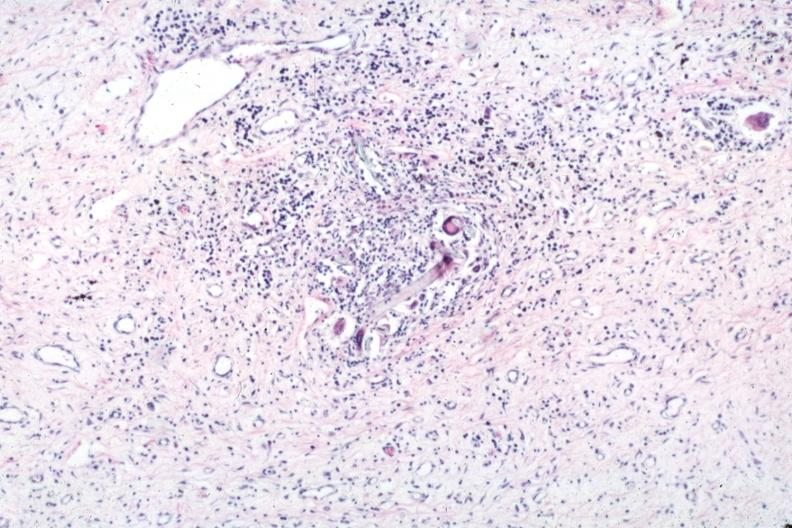does mucinous cystadenocarcinoma show typical lesion with giant cells and foreign material?
Answer the question using a single word or phrase. No 